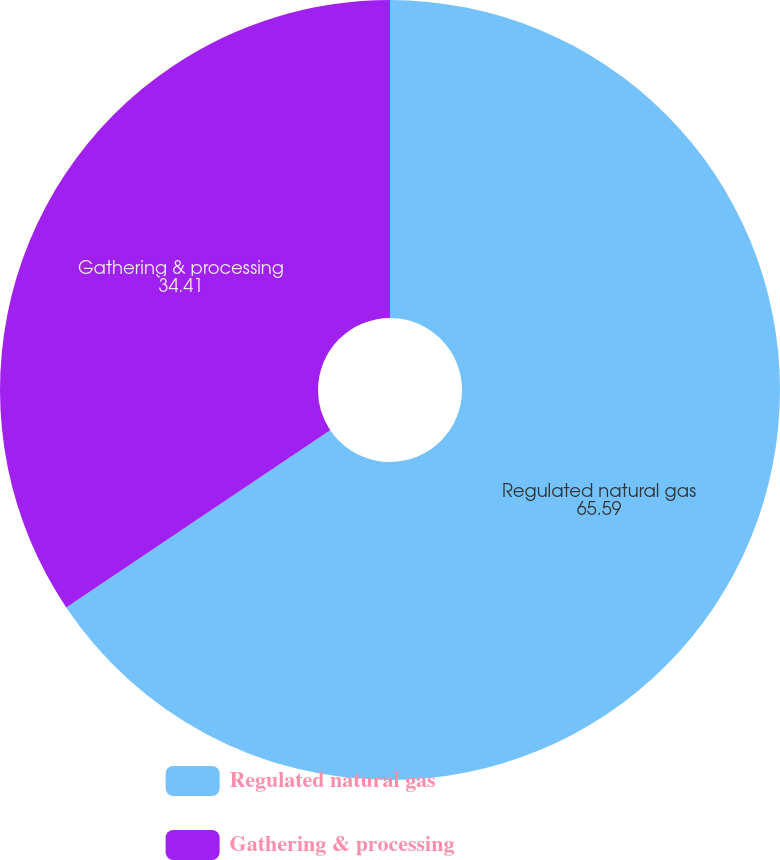Convert chart to OTSL. <chart><loc_0><loc_0><loc_500><loc_500><pie_chart><fcel>Regulated natural gas<fcel>Gathering & processing<nl><fcel>65.59%<fcel>34.41%<nl></chart> 